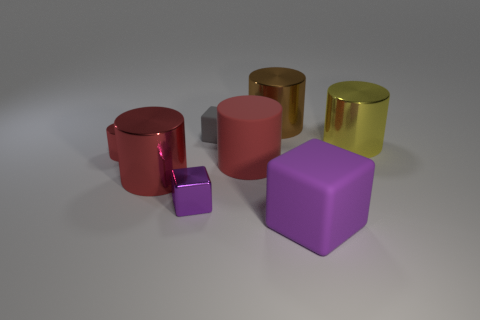Subtract all yellow blocks. How many red cylinders are left? 3 Subtract all yellow cylinders. How many cylinders are left? 4 Subtract all small metallic cylinders. How many cylinders are left? 4 Subtract all cyan cylinders. Subtract all gray spheres. How many cylinders are left? 5 Add 1 big cyan balls. How many objects exist? 9 Subtract all cylinders. How many objects are left? 3 Add 7 gray things. How many gray things exist? 8 Subtract 1 purple blocks. How many objects are left? 7 Subtract all red things. Subtract all large yellow cylinders. How many objects are left? 4 Add 8 small cylinders. How many small cylinders are left? 9 